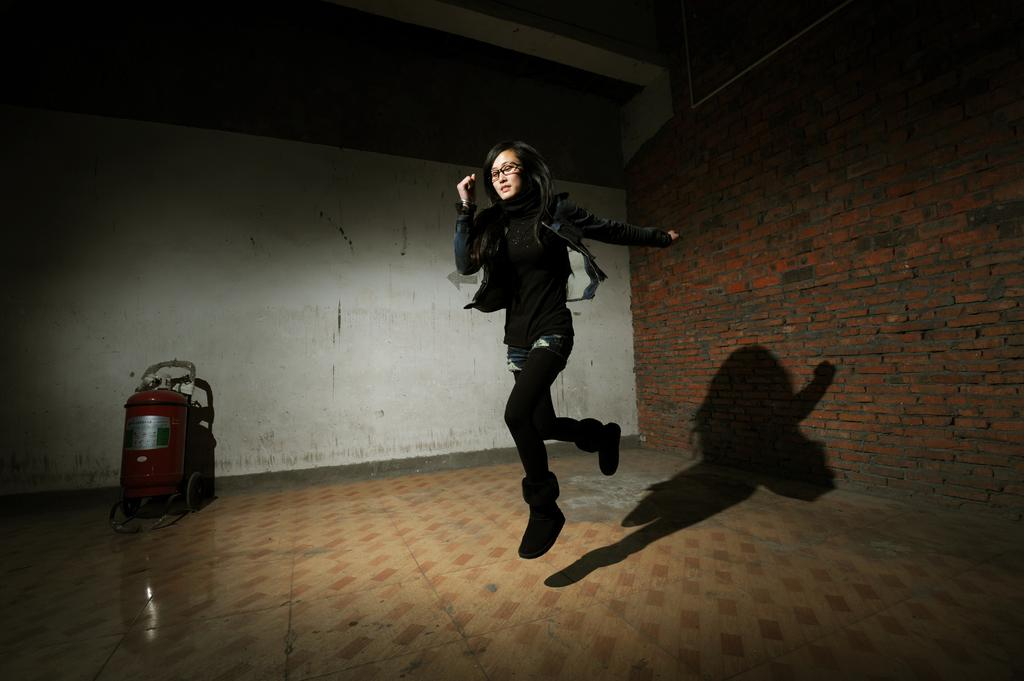Who is present in the image? There is a woman in the image. What is on the floor in the image? There is an object on the floor in the image. What can be seen in the background of the image? There is a wall visible in the background of the image. What type of bear can be seen interacting with the woman in the image? There is no bear present in the image; it only features a woman and an object on the floor. How many buttons are visible on the woman's clothing in the image? There is no information about buttons on the woman's clothing in the image. 